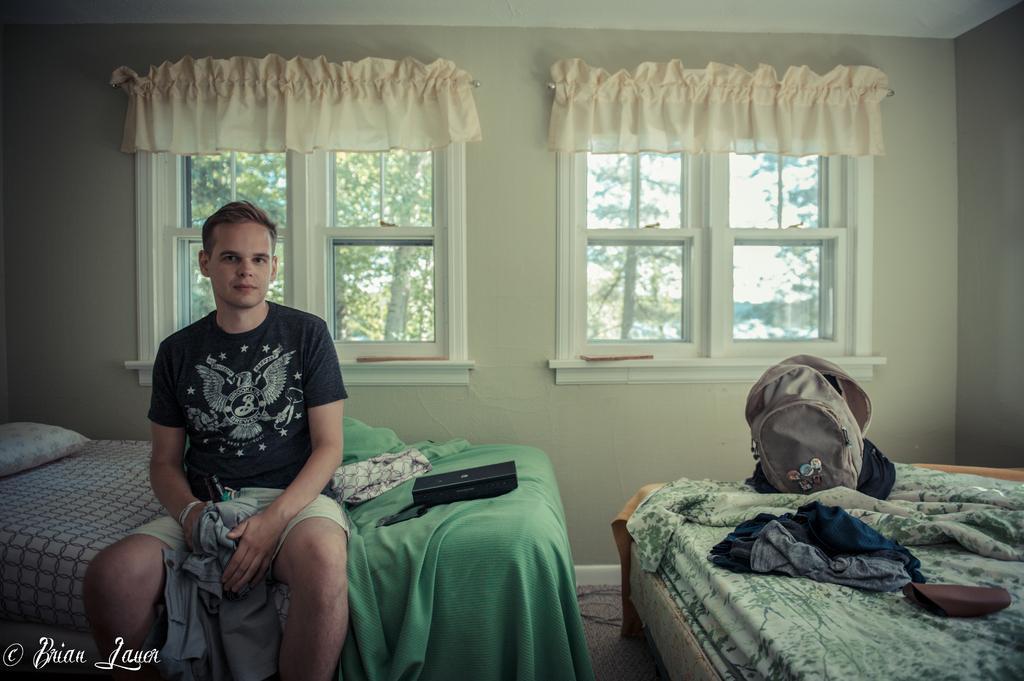Please provide a concise description of this image. The person wearing black shirt is sitting on a bed and holding a bottle with a cloth and there are windows behind him. 